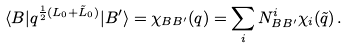Convert formula to latex. <formula><loc_0><loc_0><loc_500><loc_500>\langle B | q ^ { \frac { 1 } { 2 } ( L _ { 0 } + \tilde { L } _ { 0 } ) } | B ^ { \prime } \rangle = \chi _ { B B ^ { \prime } } ( q ) = \sum _ { i } N _ { B B ^ { \prime } } ^ { i } \chi _ { i } ( \tilde { q } ) \, .</formula> 